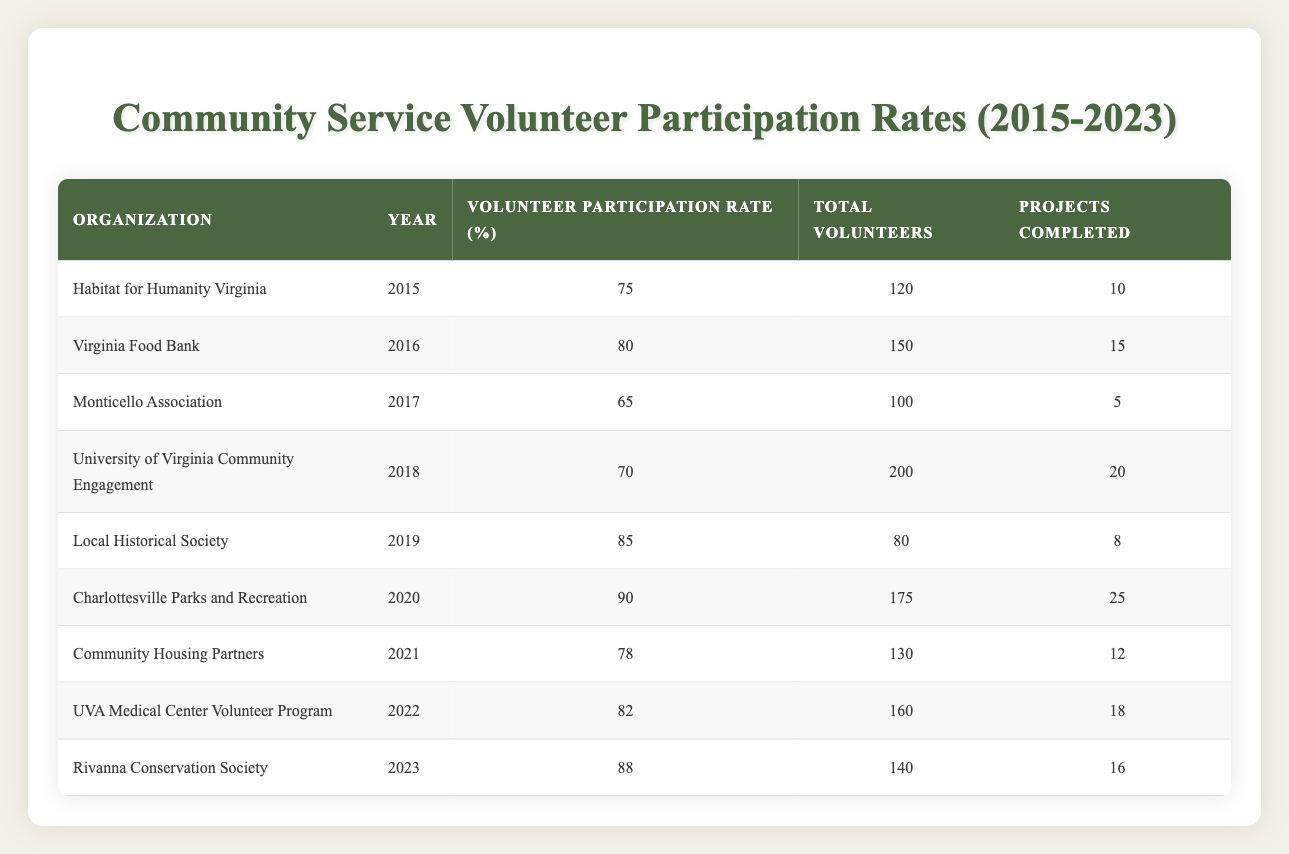What was the volunteer participation rate for Charlottesville Parks and Recreation in 2020? The table shows that the organization Charlottesville Parks and Recreation had a volunteer participation rate of 90% for the year 2020.
Answer: 90% Which organization had the highest volunteer participation rate from 2015 to 2023? By reviewing the table, the highest volunteer participation rate recorded was 90% for the organization Charlottesville Parks and Recreation in 2020.
Answer: Charlottesville Parks and Recreation What is the total number of volunteers across all organizations in 2021? To find the total number of volunteers in 2021, we look at the row for Community Housing Partners, which states they had 130 volunteers. As this is the only organization listed for 2021 in the table, the total number is 130.
Answer: 130 Was the volunteer participation rate for Local Historical Society higher than that of University of Virginia Community Engagement in 2018? The Local Historical Society had a participation rate of 85% in 2019, while the University of Virginia Community Engagement had a rate of 70% in 2018. Therefore, yes, the participation rate for Local Historical Society was higher.
Answer: Yes What is the average volunteer participation rate from 2015 to 2023? To calculate the average participation rate, we need to sum the participation rates: (75 + 80 + 65 + 70 + 85 + 90 + 78 + 82 + 88) = 818. Since there are 9 data points, we find the average by dividing the total by 9: 818 / 9 = 91. The average volunteer participation rate is 91%.
Answer: 91% Which year saw the fewest projects completed, and how many were there? The table indicates that the Monticello Association completed only 5 projects in the year 2017, which is the lowest compared to other entries in the table.
Answer: 2017, 5 projects Which organization saw the number of volunteers increase between 2015 and 2022? Comparing the total number of volunteers, Habitat for Humanity Virginia had 120 in 2015, and the University of Virginia Community Engagement had 200 in 2018, and this trend continued as evidenced by the UVA Medical Center Volunteer Program in 2022 with 160 volunteers. Hence, the increasing organizations until 2022 are evident.
Answer: University of Virginia Community Engagement Did any organization have more than 150 volunteers and a participation rate below 80%? Looking at the data, Community Housing Partners had 130 volunteers with a participation rate of 78% and the Virginia Food Bank had 150 volunteers with a participation rate of 80%. No organization with over 150 volunteers has a rate below 80%.
Answer: No 